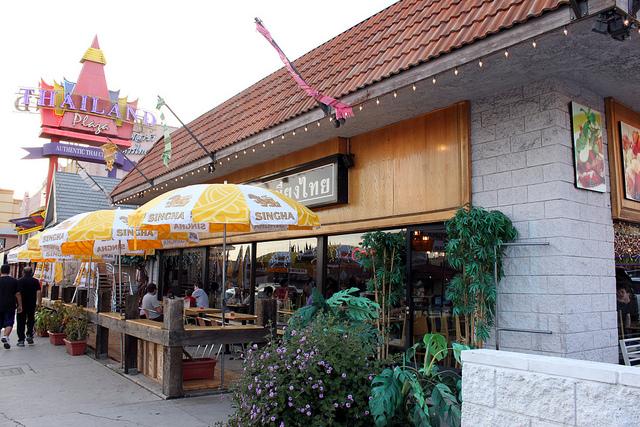Is the woman sitting?
Concise answer only. Yes. Could this be Bangkok?
Be succinct. Yes. Are there seats outside?
Concise answer only. Yes. What colors are the umbrellas?
Quick response, please. Yellow and white. 